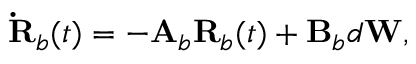Convert formula to latex. <formula><loc_0><loc_0><loc_500><loc_500>\dot { R } _ { b } ( t ) = - A _ { b } R _ { b } ( t ) + B _ { b } d W ,</formula> 